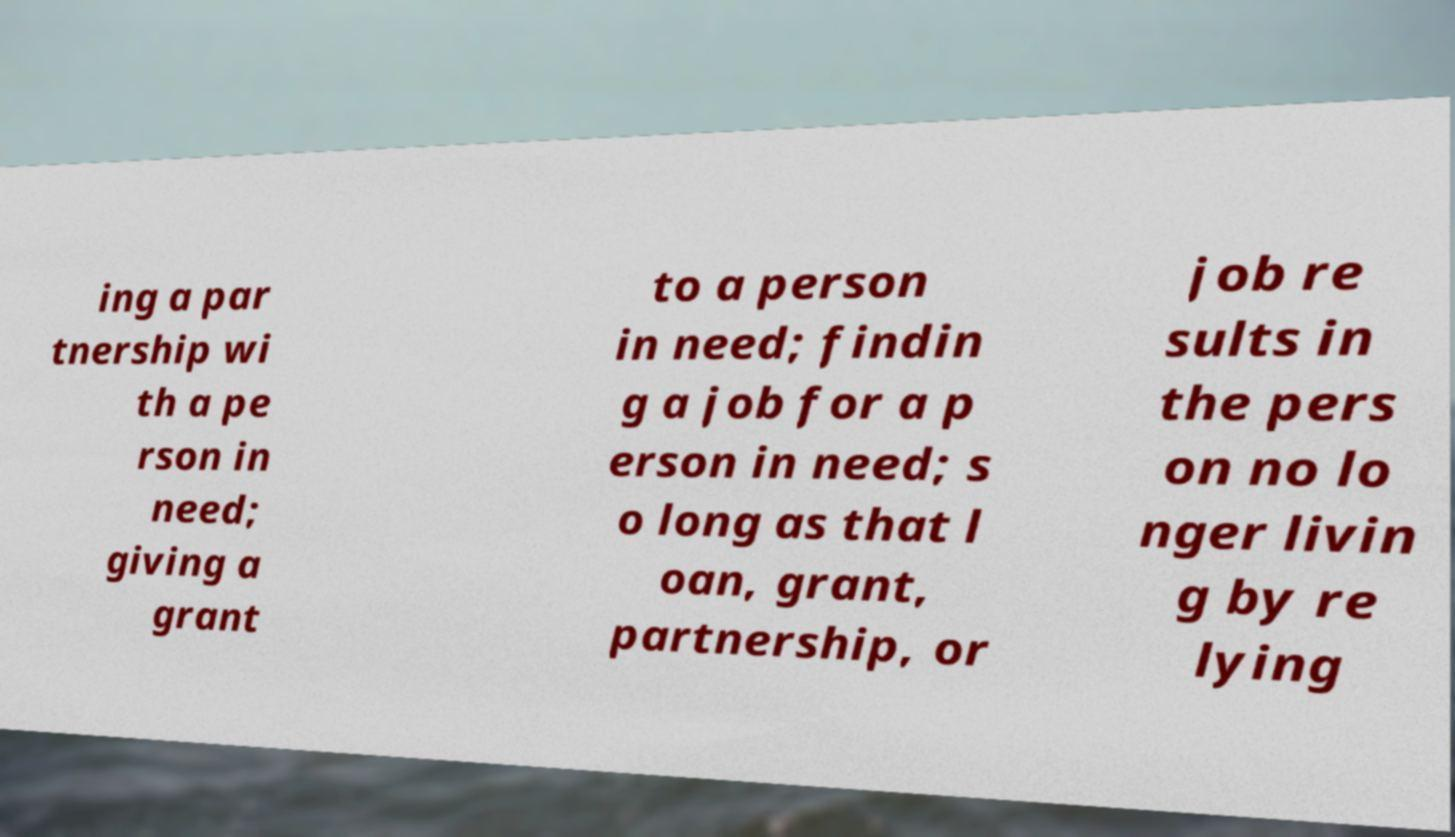I need the written content from this picture converted into text. Can you do that? ing a par tnership wi th a pe rson in need; giving a grant to a person in need; findin g a job for a p erson in need; s o long as that l oan, grant, partnership, or job re sults in the pers on no lo nger livin g by re lying 